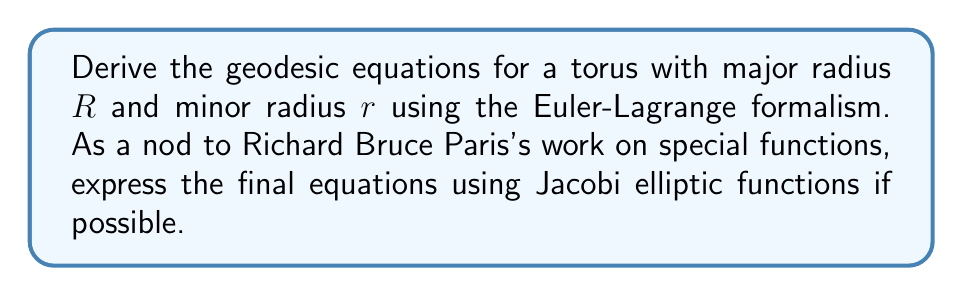Teach me how to tackle this problem. Let's approach this step-by-step:

1) First, we need to parameterize the torus. We can use the following parameterization:
   $$x = (R + r\cos\phi)\cos\theta$$
   $$y = (R + r\cos\phi)\sin\theta$$
   $$z = r\sin\phi$$
   where $0 \leq \theta < 2\pi$ and $0 \leq \phi < 2\pi$

2) The metric tensor for this parameterization is:
   $$g_{\theta\theta} = (R + r\cos\phi)^2$$
   $$g_{\phi\phi} = r^2$$
   $$g_{\theta\phi} = g_{\phi\theta} = 0$$

3) The Lagrangian for geodesics is:
   $$L = \frac{1}{2}[(R + r\cos\phi)^2\dot{\theta}^2 + r^2\dot{\phi}^2]$$
   where dots represent derivatives with respect to some parameter $s$.

4) Now, we apply the Euler-Lagrange equations:
   $$\frac{d}{ds}\left(\frac{\partial L}{\partial \dot{q}_i}\right) - \frac{\partial L}{\partial q_i} = 0$$
   for $q_i = \theta, \phi$

5) For $\theta$:
   $$\frac{d}{ds}[(R + r\cos\phi)^2\dot{\theta}] = 0$$
   This implies:
   $$(R + r\cos\phi)^2\dot{\theta} = c_1$$ (constant)

6) For $\phi$:
   $$\frac{d}{ds}(r^2\dot{\phi}) - (-r\sin\phi)(R + r\cos\phi)\dot{\theta}^2 = 0$$

7) Substituting $\dot{\theta}$ from step 5:
   $$r^2\ddot{\phi} - \frac{c_1^2r\sin\phi}{(R + r\cos\phi)^3} = 0$$

8) These are our geodesic equations. To express them using Jacobi elliptic functions, we can introduce a new variable $u = R + r\cos\phi$. Then:
   $$\dot{u}^2 = r^2\dot{\phi}^2\sin^2\phi = r^2\dot{\phi}^2 - \frac{(u^2-R^2)(2Ru-u^2)}{r^2}$$

9) This equation has the form of the differential equation satisfied by Jacobi elliptic functions. The solution can be expressed as:
   $$u = R + r\,\mathrm{cn}(\omega s, k)$$
   where $\omega$ and $k$ are constants depending on $R$, $r$, and initial conditions.

10) The equation for $\theta$ can be integrated to give:
    $$\theta = c_1 \int \frac{ds}{u^2} = c_1 \int \frac{ds}{(R + r\,\mathrm{cn}(\omega s, k))^2}$$
    This integral can be expressed in terms of elliptic integrals.
Answer: Geodesic equations: $$(R + r\cos\phi)^2\dot{\theta} = c_1$$
$$r^2\ddot{\phi} - \frac{c_1^2r\sin\phi}{(R + r\cos\phi)^3} = 0$$
Solution: $R + r\cos\phi = R + r\,\mathrm{cn}(\omega s, k)$, $\theta = c_1 \int \frac{ds}{(R + r\,\mathrm{cn}(\omega s, k))^2}$ 